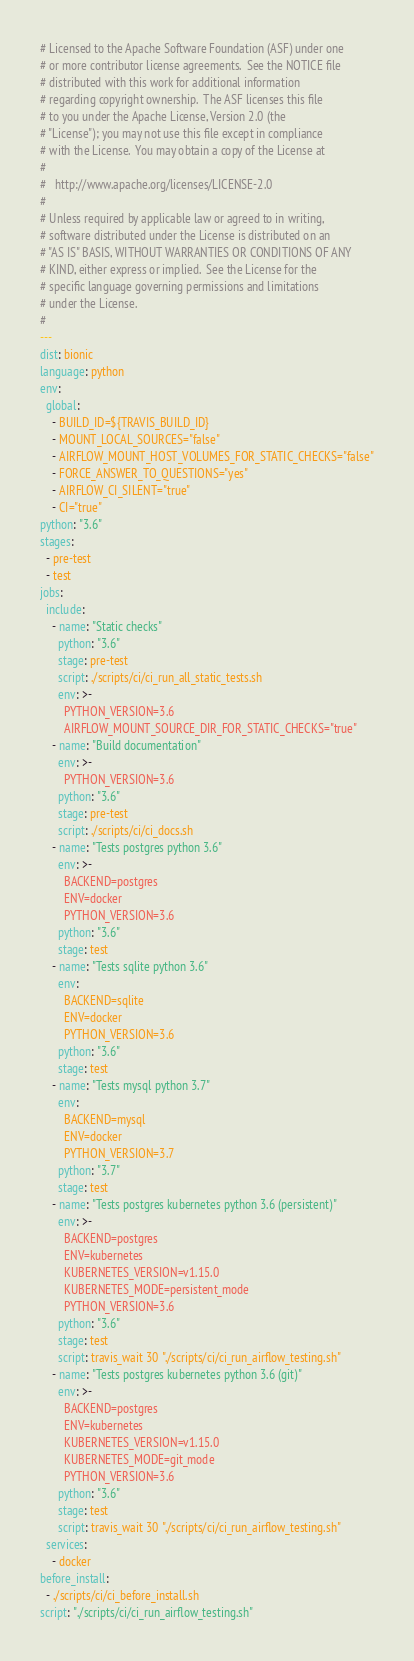Convert code to text. <code><loc_0><loc_0><loc_500><loc_500><_YAML_># Licensed to the Apache Software Foundation (ASF) under one
# or more contributor license agreements.  See the NOTICE file
# distributed with this work for additional information
# regarding copyright ownership.  The ASF licenses this file
# to you under the Apache License, Version 2.0 (the
# "License"); you may not use this file except in compliance
# with the License.  You may obtain a copy of the License at
#
#   http://www.apache.org/licenses/LICENSE-2.0
#
# Unless required by applicable law or agreed to in writing,
# software distributed under the License is distributed on an
# "AS IS" BASIS, WITHOUT WARRANTIES OR CONDITIONS OF ANY
# KIND, either express or implied.  See the License for the
# specific language governing permissions and limitations
# under the License.
#
---
dist: bionic
language: python
env:
  global:
    - BUILD_ID=${TRAVIS_BUILD_ID}
    - MOUNT_LOCAL_SOURCES="false"
    - AIRFLOW_MOUNT_HOST_VOLUMES_FOR_STATIC_CHECKS="false"
    - FORCE_ANSWER_TO_QUESTIONS="yes"
    - AIRFLOW_CI_SILENT="true"
    - CI="true"
python: "3.6"
stages:
  - pre-test
  - test
jobs:
  include:
    - name: "Static checks"
      python: "3.6"
      stage: pre-test
      script: ./scripts/ci/ci_run_all_static_tests.sh
      env: >-
        PYTHON_VERSION=3.6
        AIRFLOW_MOUNT_SOURCE_DIR_FOR_STATIC_CHECKS="true"
    - name: "Build documentation"
      env: >-
        PYTHON_VERSION=3.6
      python: "3.6"
      stage: pre-test
      script: ./scripts/ci/ci_docs.sh
    - name: "Tests postgres python 3.6"
      env: >-
        BACKEND=postgres
        ENV=docker
        PYTHON_VERSION=3.6
      python: "3.6"
      stage: test
    - name: "Tests sqlite python 3.6"
      env:
        BACKEND=sqlite
        ENV=docker
        PYTHON_VERSION=3.6
      python: "3.6"
      stage: test
    - name: "Tests mysql python 3.7"
      env:
        BACKEND=mysql
        ENV=docker
        PYTHON_VERSION=3.7
      python: "3.7"
      stage: test
    - name: "Tests postgres kubernetes python 3.6 (persistent)"
      env: >-
        BACKEND=postgres
        ENV=kubernetes
        KUBERNETES_VERSION=v1.15.0
        KUBERNETES_MODE=persistent_mode
        PYTHON_VERSION=3.6
      python: "3.6"
      stage: test
      script: travis_wait 30 "./scripts/ci/ci_run_airflow_testing.sh"
    - name: "Tests postgres kubernetes python 3.6 (git)"
      env: >-
        BACKEND=postgres
        ENV=kubernetes
        KUBERNETES_VERSION=v1.15.0
        KUBERNETES_MODE=git_mode
        PYTHON_VERSION=3.6
      python: "3.6"
      stage: test
      script: travis_wait 30 "./scripts/ci/ci_run_airflow_testing.sh"
  services:
    - docker
before_install:
  - ./scripts/ci/ci_before_install.sh
script: "./scripts/ci/ci_run_airflow_testing.sh"
</code> 